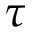Convert formula to latex. <formula><loc_0><loc_0><loc_500><loc_500>\tau</formula> 